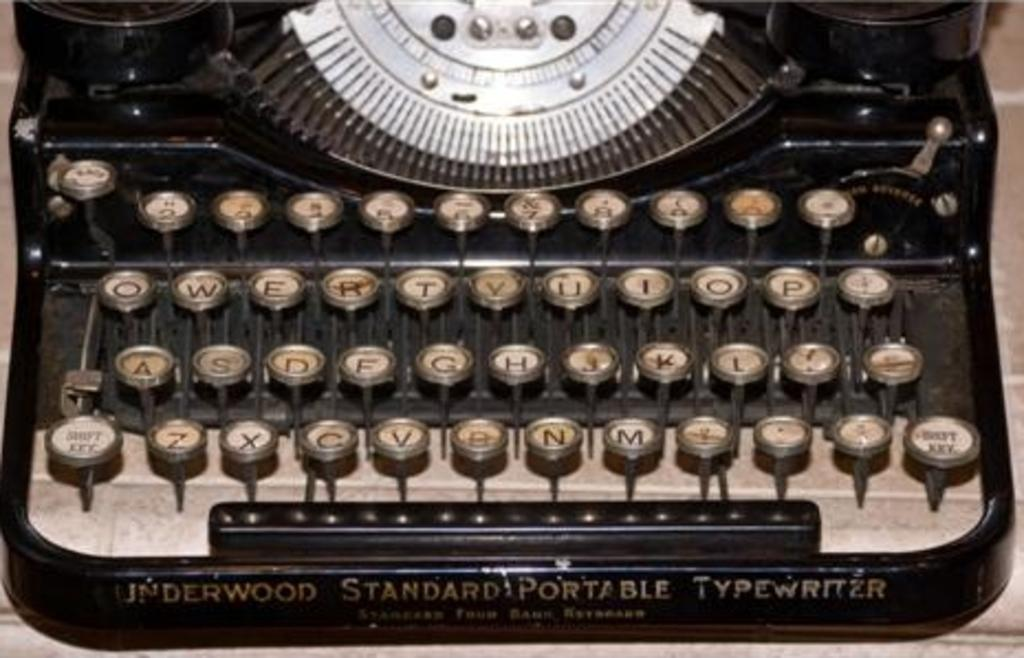Provide a one-sentence caption for the provided image. Underwood produced Standard Portable Typewriters quite awhile ago. 